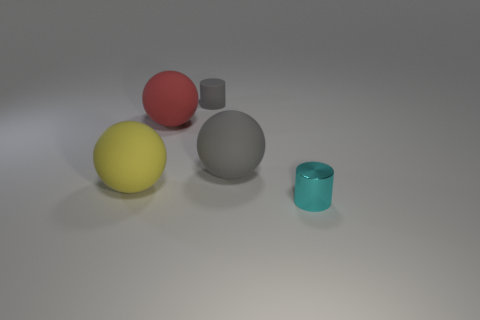Add 1 tiny gray rubber things. How many objects exist? 6 Subtract all balls. How many objects are left? 2 Subtract 0 brown blocks. How many objects are left? 5 Subtract all small green balls. Subtract all small cyan shiny objects. How many objects are left? 4 Add 5 gray matte cylinders. How many gray matte cylinders are left? 6 Add 4 small shiny cylinders. How many small shiny cylinders exist? 5 